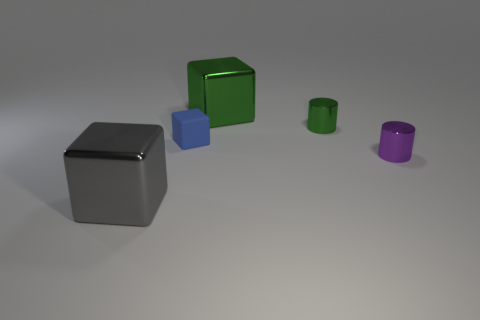Add 4 tiny cylinders. How many objects exist? 9 Subtract all blocks. How many objects are left? 2 Subtract all spheres. Subtract all big blocks. How many objects are left? 3 Add 1 large gray things. How many large gray things are left? 2 Add 4 brown rubber spheres. How many brown rubber spheres exist? 4 Subtract 0 blue balls. How many objects are left? 5 